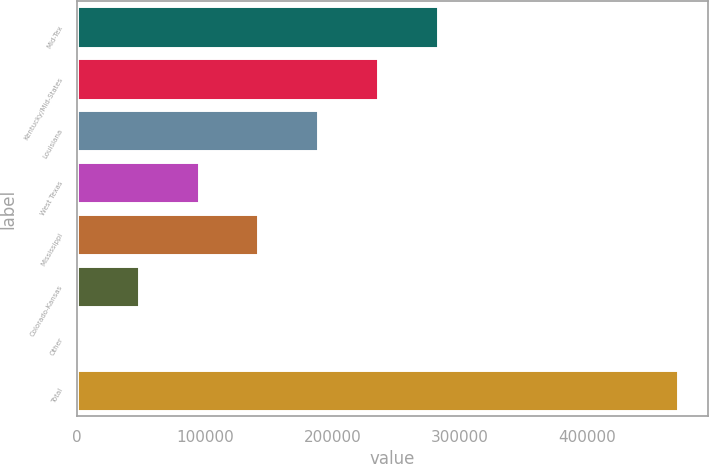<chart> <loc_0><loc_0><loc_500><loc_500><bar_chart><fcel>Mid-Tex<fcel>Kentucky/Mid-States<fcel>Louisiana<fcel>West Texas<fcel>Mississippi<fcel>Colorado-Kansas<fcel>Other<fcel>Total<nl><fcel>282934<fcel>235974<fcel>189014<fcel>95095.2<fcel>142055<fcel>48135.6<fcel>1176<fcel>470772<nl></chart> 